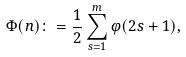Convert formula to latex. <formula><loc_0><loc_0><loc_500><loc_500>\Phi ( n ) \colon = \frac { 1 } { 2 } \sum _ { s = 1 } ^ { m } \varphi ( 2 s + 1 ) ,</formula> 